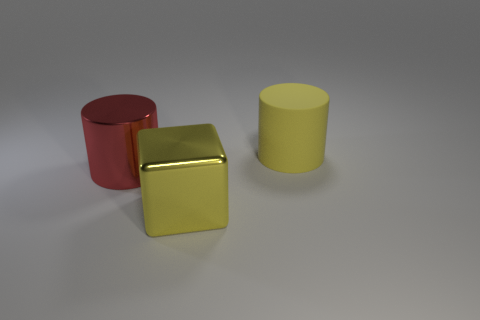Add 2 brown spheres. How many objects exist? 5 Subtract all yellow cylinders. How many cylinders are left? 1 Subtract all cylinders. How many objects are left? 1 Subtract 0 brown blocks. How many objects are left? 3 Subtract all gray cylinders. Subtract all purple balls. How many cylinders are left? 2 Subtract all large yellow rubber objects. Subtract all big yellow matte cylinders. How many objects are left? 1 Add 2 cubes. How many cubes are left? 3 Add 3 red objects. How many red objects exist? 4 